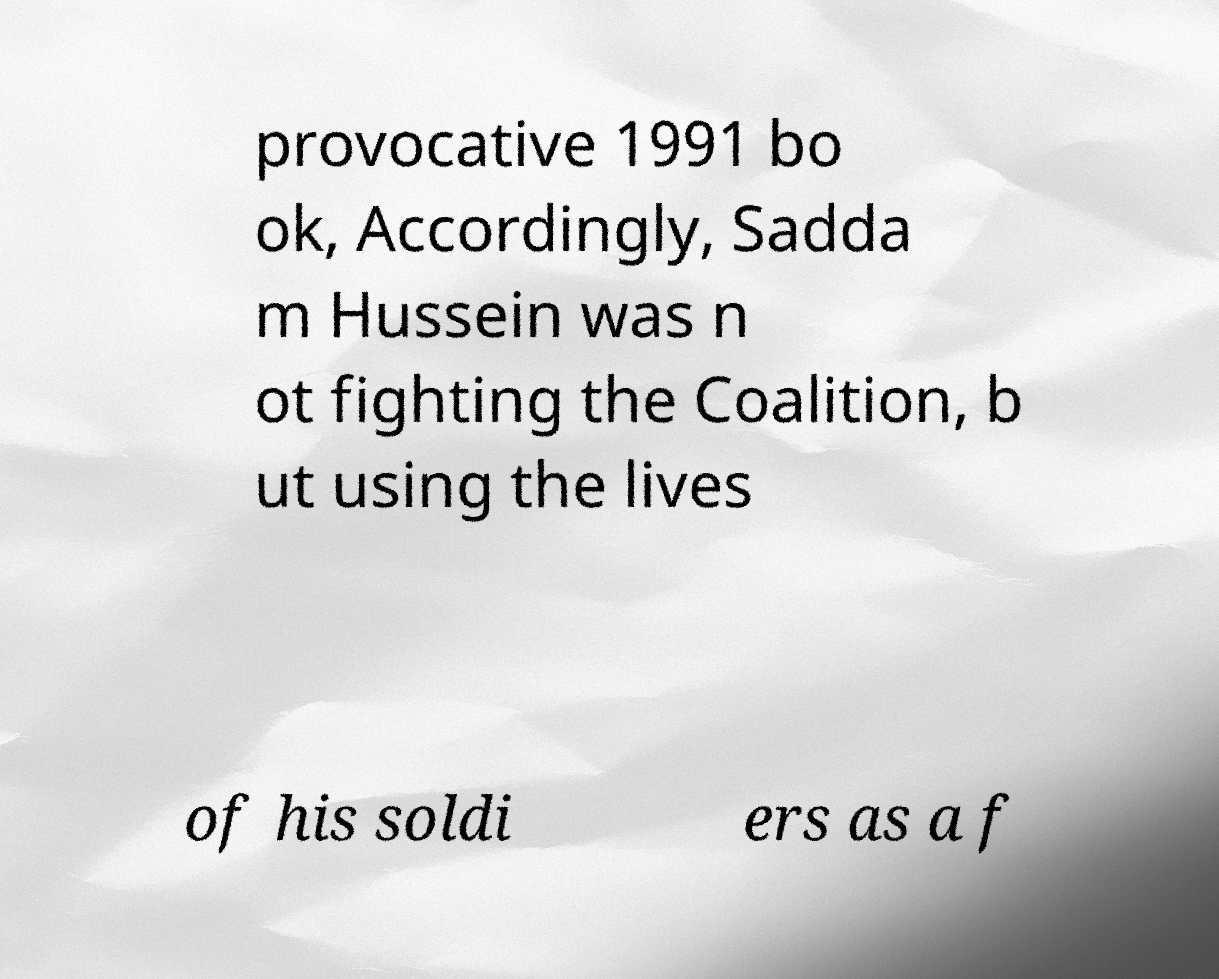Can you read and provide the text displayed in the image?This photo seems to have some interesting text. Can you extract and type it out for me? provocative 1991 bo ok, Accordingly, Sadda m Hussein was n ot fighting the Coalition, b ut using the lives of his soldi ers as a f 